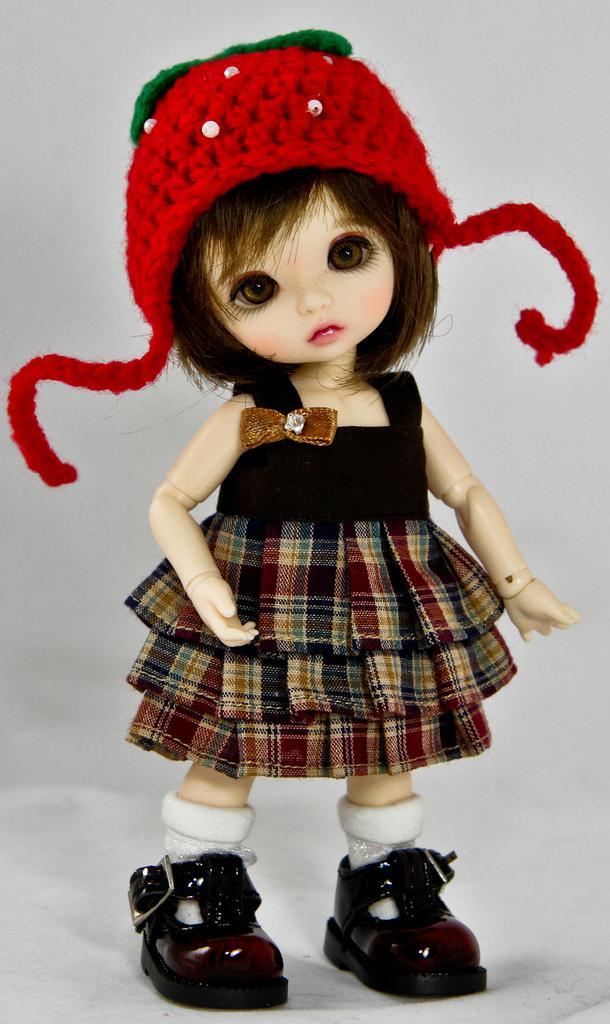Could you give a brief overview of what you see in this image? In this image there is a girl toy wearing a dress, cap and shoes. Background is in white color. 